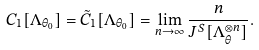Convert formula to latex. <formula><loc_0><loc_0><loc_500><loc_500>C _ { 1 } [ \Lambda _ { \theta _ { 0 } } ] = \tilde { C } _ { 1 } [ \Lambda _ { \theta _ { 0 } } ] = \lim _ { n \to \infty } \frac { n } { J ^ { S } [ \Lambda _ { \theta } ^ { \otimes n } ] } .</formula> 